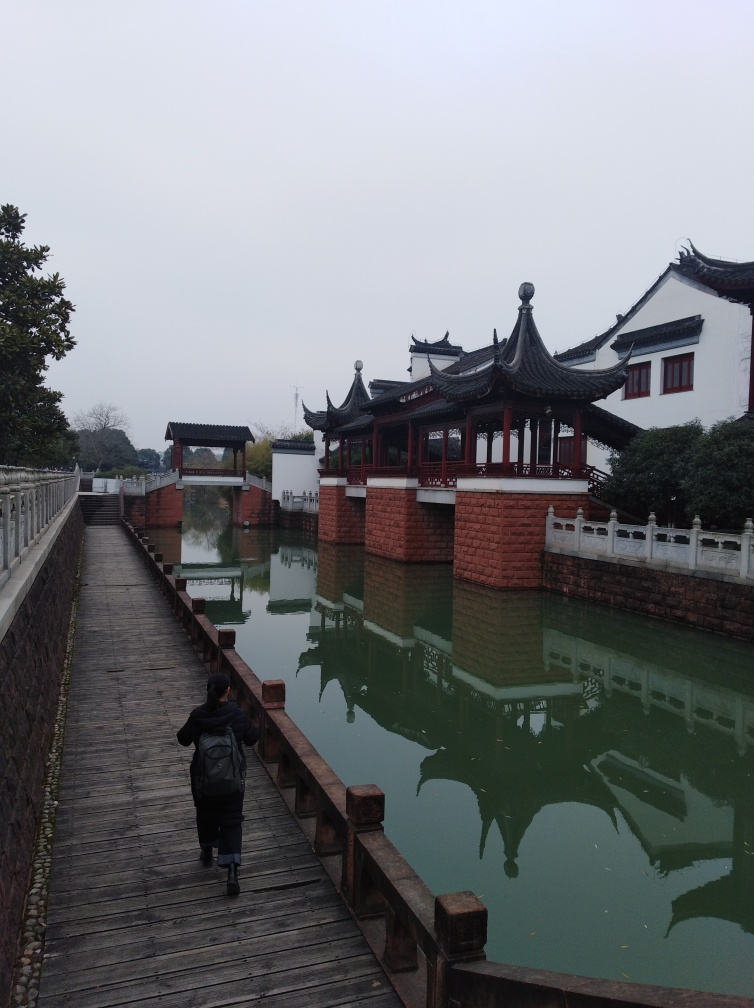What can you tell me about the architecture style in the image? The architecture style in the image is traditional Chinese, likely reflecting ancient building techniques. You can see the upswept eaves and multiples tiers in the roofing, along with decorative elements that are staples of classic Chinese pagodas and buildings. These designs are not only visually pleasing but also carry cultural significance, often embodying principles of harmony and balance. Does the weather affect the ambiance of the scene? Absolutely, the overcast sky in the image casts a soft, diffused light over the scene, which enhances the calm and introspective atmosphere. The lack of harsh shadows contributes to a serene and somewhat melancholic mood, which is typical for scenes captured on cloudy days. 